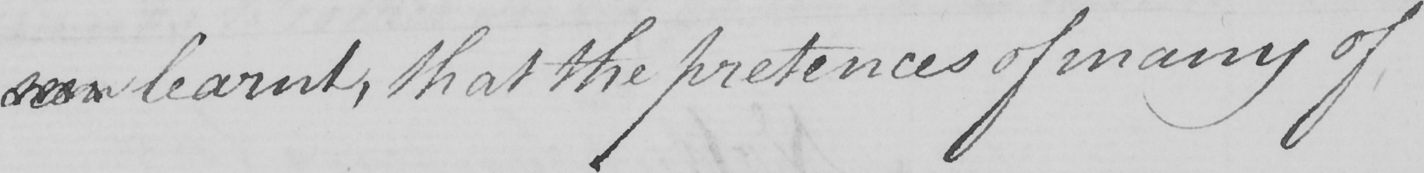Can you tell me what this handwritten text says? seen learnt , that the pretences of many of 